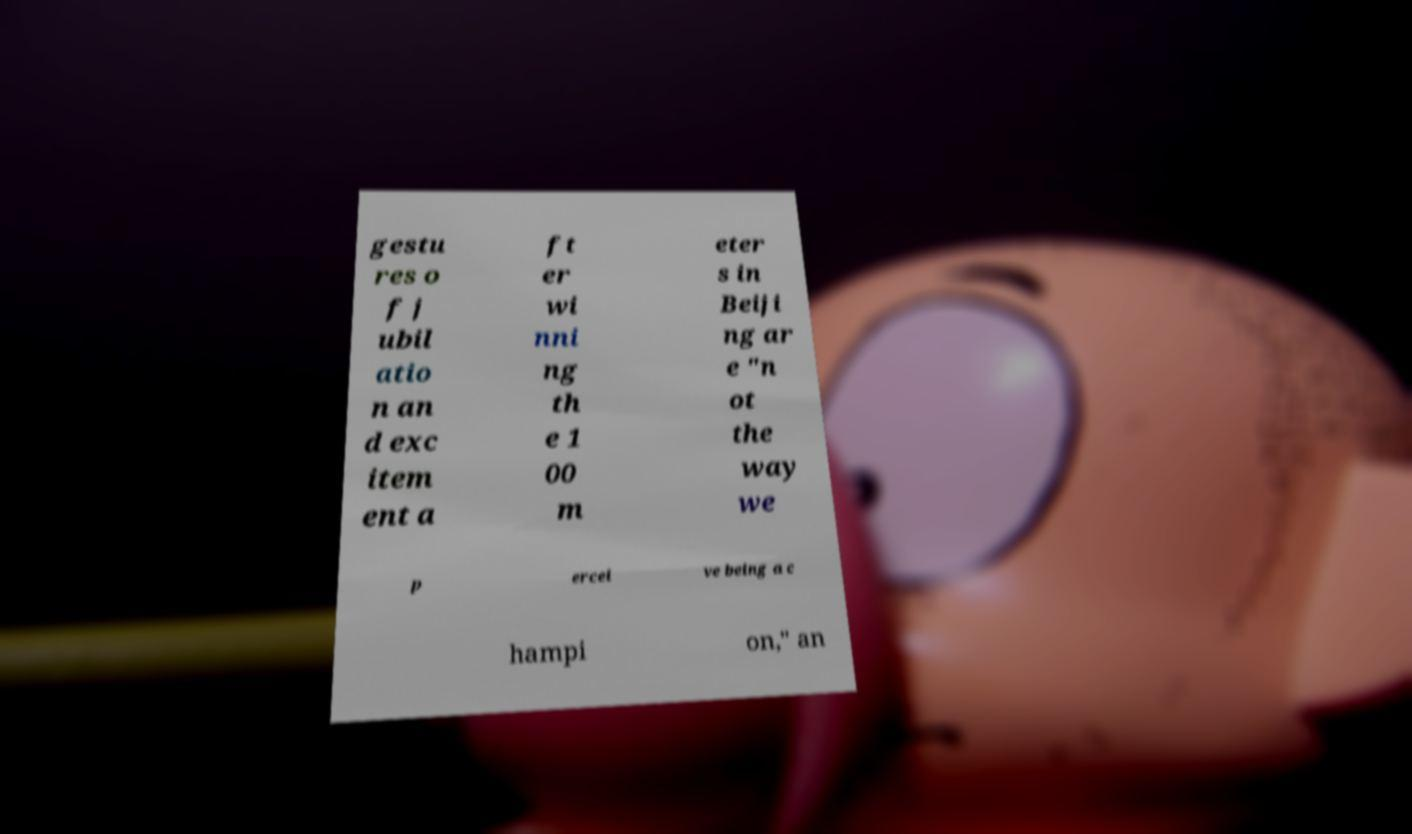Please read and relay the text visible in this image. What does it say? gestu res o f j ubil atio n an d exc item ent a ft er wi nni ng th e 1 00 m eter s in Beiji ng ar e "n ot the way we p ercei ve being a c hampi on," an 